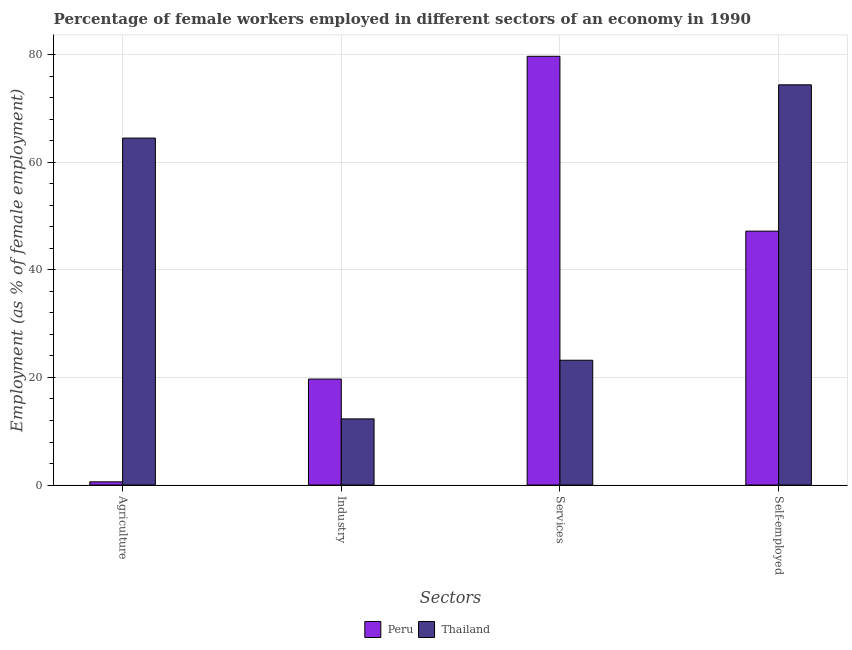How many different coloured bars are there?
Offer a very short reply. 2. How many groups of bars are there?
Ensure brevity in your answer.  4. Are the number of bars per tick equal to the number of legend labels?
Give a very brief answer. Yes. Are the number of bars on each tick of the X-axis equal?
Your response must be concise. Yes. How many bars are there on the 1st tick from the left?
Provide a succinct answer. 2. What is the label of the 1st group of bars from the left?
Offer a terse response. Agriculture. What is the percentage of female workers in agriculture in Peru?
Your response must be concise. 0.6. Across all countries, what is the maximum percentage of self employed female workers?
Make the answer very short. 74.4. Across all countries, what is the minimum percentage of female workers in agriculture?
Your answer should be very brief. 0.6. In which country was the percentage of female workers in services maximum?
Keep it short and to the point. Peru. In which country was the percentage of female workers in agriculture minimum?
Your answer should be compact. Peru. What is the total percentage of self employed female workers in the graph?
Ensure brevity in your answer.  121.6. What is the difference between the percentage of female workers in services in Thailand and that in Peru?
Offer a terse response. -56.5. What is the difference between the percentage of female workers in services in Peru and the percentage of female workers in industry in Thailand?
Your answer should be very brief. 67.4. What is the average percentage of female workers in agriculture per country?
Ensure brevity in your answer.  32.55. What is the difference between the percentage of female workers in agriculture and percentage of female workers in industry in Thailand?
Offer a terse response. 52.2. In how many countries, is the percentage of female workers in industry greater than 60 %?
Your response must be concise. 0. What is the ratio of the percentage of female workers in services in Peru to that in Thailand?
Make the answer very short. 3.44. What is the difference between the highest and the second highest percentage of female workers in industry?
Offer a terse response. 7.4. What is the difference between the highest and the lowest percentage of self employed female workers?
Give a very brief answer. 27.2. In how many countries, is the percentage of female workers in industry greater than the average percentage of female workers in industry taken over all countries?
Provide a succinct answer. 1. Is the sum of the percentage of self employed female workers in Thailand and Peru greater than the maximum percentage of female workers in industry across all countries?
Make the answer very short. Yes. Is it the case that in every country, the sum of the percentage of self employed female workers and percentage of female workers in services is greater than the sum of percentage of female workers in agriculture and percentage of female workers in industry?
Your response must be concise. No. What does the 2nd bar from the left in Industry represents?
Give a very brief answer. Thailand. What does the 2nd bar from the right in Industry represents?
Give a very brief answer. Peru. Are all the bars in the graph horizontal?
Offer a terse response. No. Are the values on the major ticks of Y-axis written in scientific E-notation?
Your response must be concise. No. Does the graph contain any zero values?
Keep it short and to the point. No. Where does the legend appear in the graph?
Make the answer very short. Bottom center. How are the legend labels stacked?
Your response must be concise. Horizontal. What is the title of the graph?
Offer a very short reply. Percentage of female workers employed in different sectors of an economy in 1990. What is the label or title of the X-axis?
Provide a succinct answer. Sectors. What is the label or title of the Y-axis?
Your answer should be very brief. Employment (as % of female employment). What is the Employment (as % of female employment) of Peru in Agriculture?
Your response must be concise. 0.6. What is the Employment (as % of female employment) of Thailand in Agriculture?
Provide a succinct answer. 64.5. What is the Employment (as % of female employment) of Peru in Industry?
Your answer should be very brief. 19.7. What is the Employment (as % of female employment) in Thailand in Industry?
Provide a short and direct response. 12.3. What is the Employment (as % of female employment) of Peru in Services?
Your response must be concise. 79.7. What is the Employment (as % of female employment) in Thailand in Services?
Offer a terse response. 23.2. What is the Employment (as % of female employment) in Peru in Self-employed?
Your response must be concise. 47.2. What is the Employment (as % of female employment) in Thailand in Self-employed?
Provide a succinct answer. 74.4. Across all Sectors, what is the maximum Employment (as % of female employment) in Peru?
Keep it short and to the point. 79.7. Across all Sectors, what is the maximum Employment (as % of female employment) in Thailand?
Give a very brief answer. 74.4. Across all Sectors, what is the minimum Employment (as % of female employment) of Peru?
Provide a succinct answer. 0.6. Across all Sectors, what is the minimum Employment (as % of female employment) of Thailand?
Offer a terse response. 12.3. What is the total Employment (as % of female employment) of Peru in the graph?
Provide a succinct answer. 147.2. What is the total Employment (as % of female employment) in Thailand in the graph?
Offer a very short reply. 174.4. What is the difference between the Employment (as % of female employment) in Peru in Agriculture and that in Industry?
Provide a short and direct response. -19.1. What is the difference between the Employment (as % of female employment) of Thailand in Agriculture and that in Industry?
Offer a terse response. 52.2. What is the difference between the Employment (as % of female employment) of Peru in Agriculture and that in Services?
Make the answer very short. -79.1. What is the difference between the Employment (as % of female employment) of Thailand in Agriculture and that in Services?
Make the answer very short. 41.3. What is the difference between the Employment (as % of female employment) in Peru in Agriculture and that in Self-employed?
Your answer should be very brief. -46.6. What is the difference between the Employment (as % of female employment) in Thailand in Agriculture and that in Self-employed?
Give a very brief answer. -9.9. What is the difference between the Employment (as % of female employment) in Peru in Industry and that in Services?
Your answer should be very brief. -60. What is the difference between the Employment (as % of female employment) of Thailand in Industry and that in Services?
Make the answer very short. -10.9. What is the difference between the Employment (as % of female employment) of Peru in Industry and that in Self-employed?
Provide a short and direct response. -27.5. What is the difference between the Employment (as % of female employment) in Thailand in Industry and that in Self-employed?
Make the answer very short. -62.1. What is the difference between the Employment (as % of female employment) of Peru in Services and that in Self-employed?
Offer a very short reply. 32.5. What is the difference between the Employment (as % of female employment) of Thailand in Services and that in Self-employed?
Provide a succinct answer. -51.2. What is the difference between the Employment (as % of female employment) in Peru in Agriculture and the Employment (as % of female employment) in Thailand in Services?
Make the answer very short. -22.6. What is the difference between the Employment (as % of female employment) of Peru in Agriculture and the Employment (as % of female employment) of Thailand in Self-employed?
Your response must be concise. -73.8. What is the difference between the Employment (as % of female employment) in Peru in Industry and the Employment (as % of female employment) in Thailand in Services?
Your answer should be very brief. -3.5. What is the difference between the Employment (as % of female employment) in Peru in Industry and the Employment (as % of female employment) in Thailand in Self-employed?
Keep it short and to the point. -54.7. What is the average Employment (as % of female employment) in Peru per Sectors?
Keep it short and to the point. 36.8. What is the average Employment (as % of female employment) of Thailand per Sectors?
Offer a terse response. 43.6. What is the difference between the Employment (as % of female employment) in Peru and Employment (as % of female employment) in Thailand in Agriculture?
Keep it short and to the point. -63.9. What is the difference between the Employment (as % of female employment) in Peru and Employment (as % of female employment) in Thailand in Services?
Keep it short and to the point. 56.5. What is the difference between the Employment (as % of female employment) of Peru and Employment (as % of female employment) of Thailand in Self-employed?
Provide a succinct answer. -27.2. What is the ratio of the Employment (as % of female employment) of Peru in Agriculture to that in Industry?
Provide a succinct answer. 0.03. What is the ratio of the Employment (as % of female employment) of Thailand in Agriculture to that in Industry?
Ensure brevity in your answer.  5.24. What is the ratio of the Employment (as % of female employment) of Peru in Agriculture to that in Services?
Your answer should be compact. 0.01. What is the ratio of the Employment (as % of female employment) of Thailand in Agriculture to that in Services?
Your response must be concise. 2.78. What is the ratio of the Employment (as % of female employment) in Peru in Agriculture to that in Self-employed?
Make the answer very short. 0.01. What is the ratio of the Employment (as % of female employment) of Thailand in Agriculture to that in Self-employed?
Provide a succinct answer. 0.87. What is the ratio of the Employment (as % of female employment) of Peru in Industry to that in Services?
Offer a very short reply. 0.25. What is the ratio of the Employment (as % of female employment) of Thailand in Industry to that in Services?
Make the answer very short. 0.53. What is the ratio of the Employment (as % of female employment) in Peru in Industry to that in Self-employed?
Give a very brief answer. 0.42. What is the ratio of the Employment (as % of female employment) in Thailand in Industry to that in Self-employed?
Keep it short and to the point. 0.17. What is the ratio of the Employment (as % of female employment) of Peru in Services to that in Self-employed?
Provide a succinct answer. 1.69. What is the ratio of the Employment (as % of female employment) of Thailand in Services to that in Self-employed?
Give a very brief answer. 0.31. What is the difference between the highest and the second highest Employment (as % of female employment) in Peru?
Provide a short and direct response. 32.5. What is the difference between the highest and the second highest Employment (as % of female employment) in Thailand?
Provide a short and direct response. 9.9. What is the difference between the highest and the lowest Employment (as % of female employment) of Peru?
Give a very brief answer. 79.1. What is the difference between the highest and the lowest Employment (as % of female employment) in Thailand?
Make the answer very short. 62.1. 